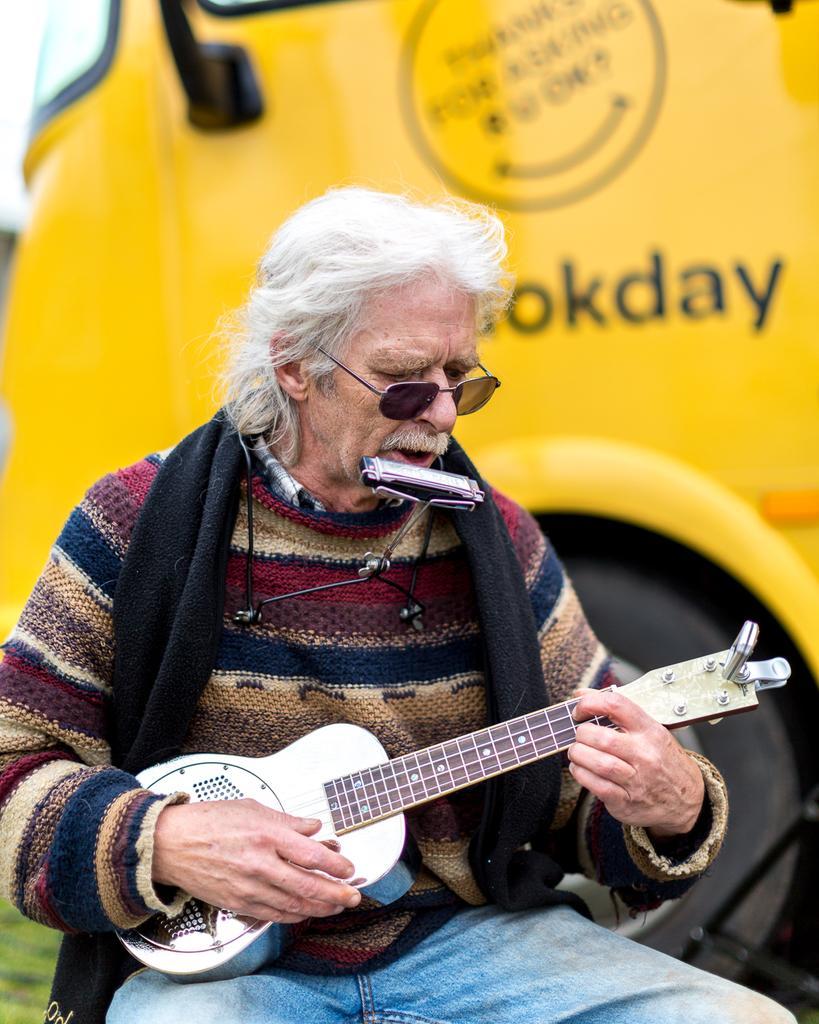In one or two sentences, can you explain what this image depicts? In a picture a person is sitting and playing guitar there is a mouth organ near to his mouth there is also a vehicle present behind him. 